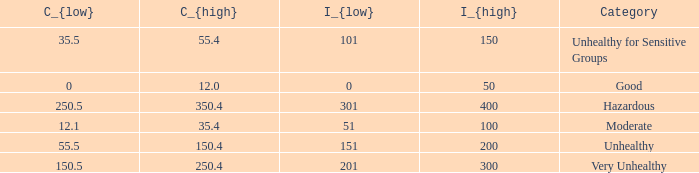How many different C_{high} values are there for the good category? 1.0. Write the full table. {'header': ['C_{low}', 'C_{high}', 'I_{low}', 'I_{high}', 'Category'], 'rows': [['35.5', '55.4', '101', '150', 'Unhealthy for Sensitive Groups'], ['0', '12.0', '0', '50', 'Good'], ['250.5', '350.4', '301', '400', 'Hazardous'], ['12.1', '35.4', '51', '100', 'Moderate'], ['55.5', '150.4', '151', '200', 'Unhealthy'], ['150.5', '250.4', '201', '300', 'Very Unhealthy']]} 